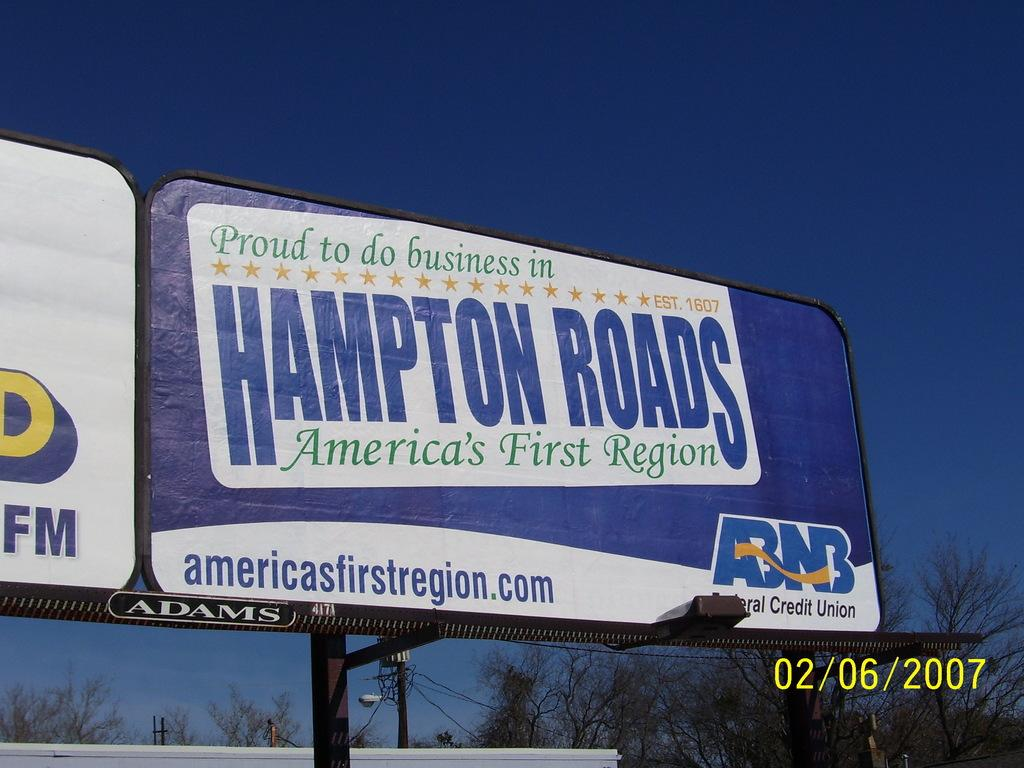<image>
Write a terse but informative summary of the picture. a billboard for hampton roads was taken in 2007 